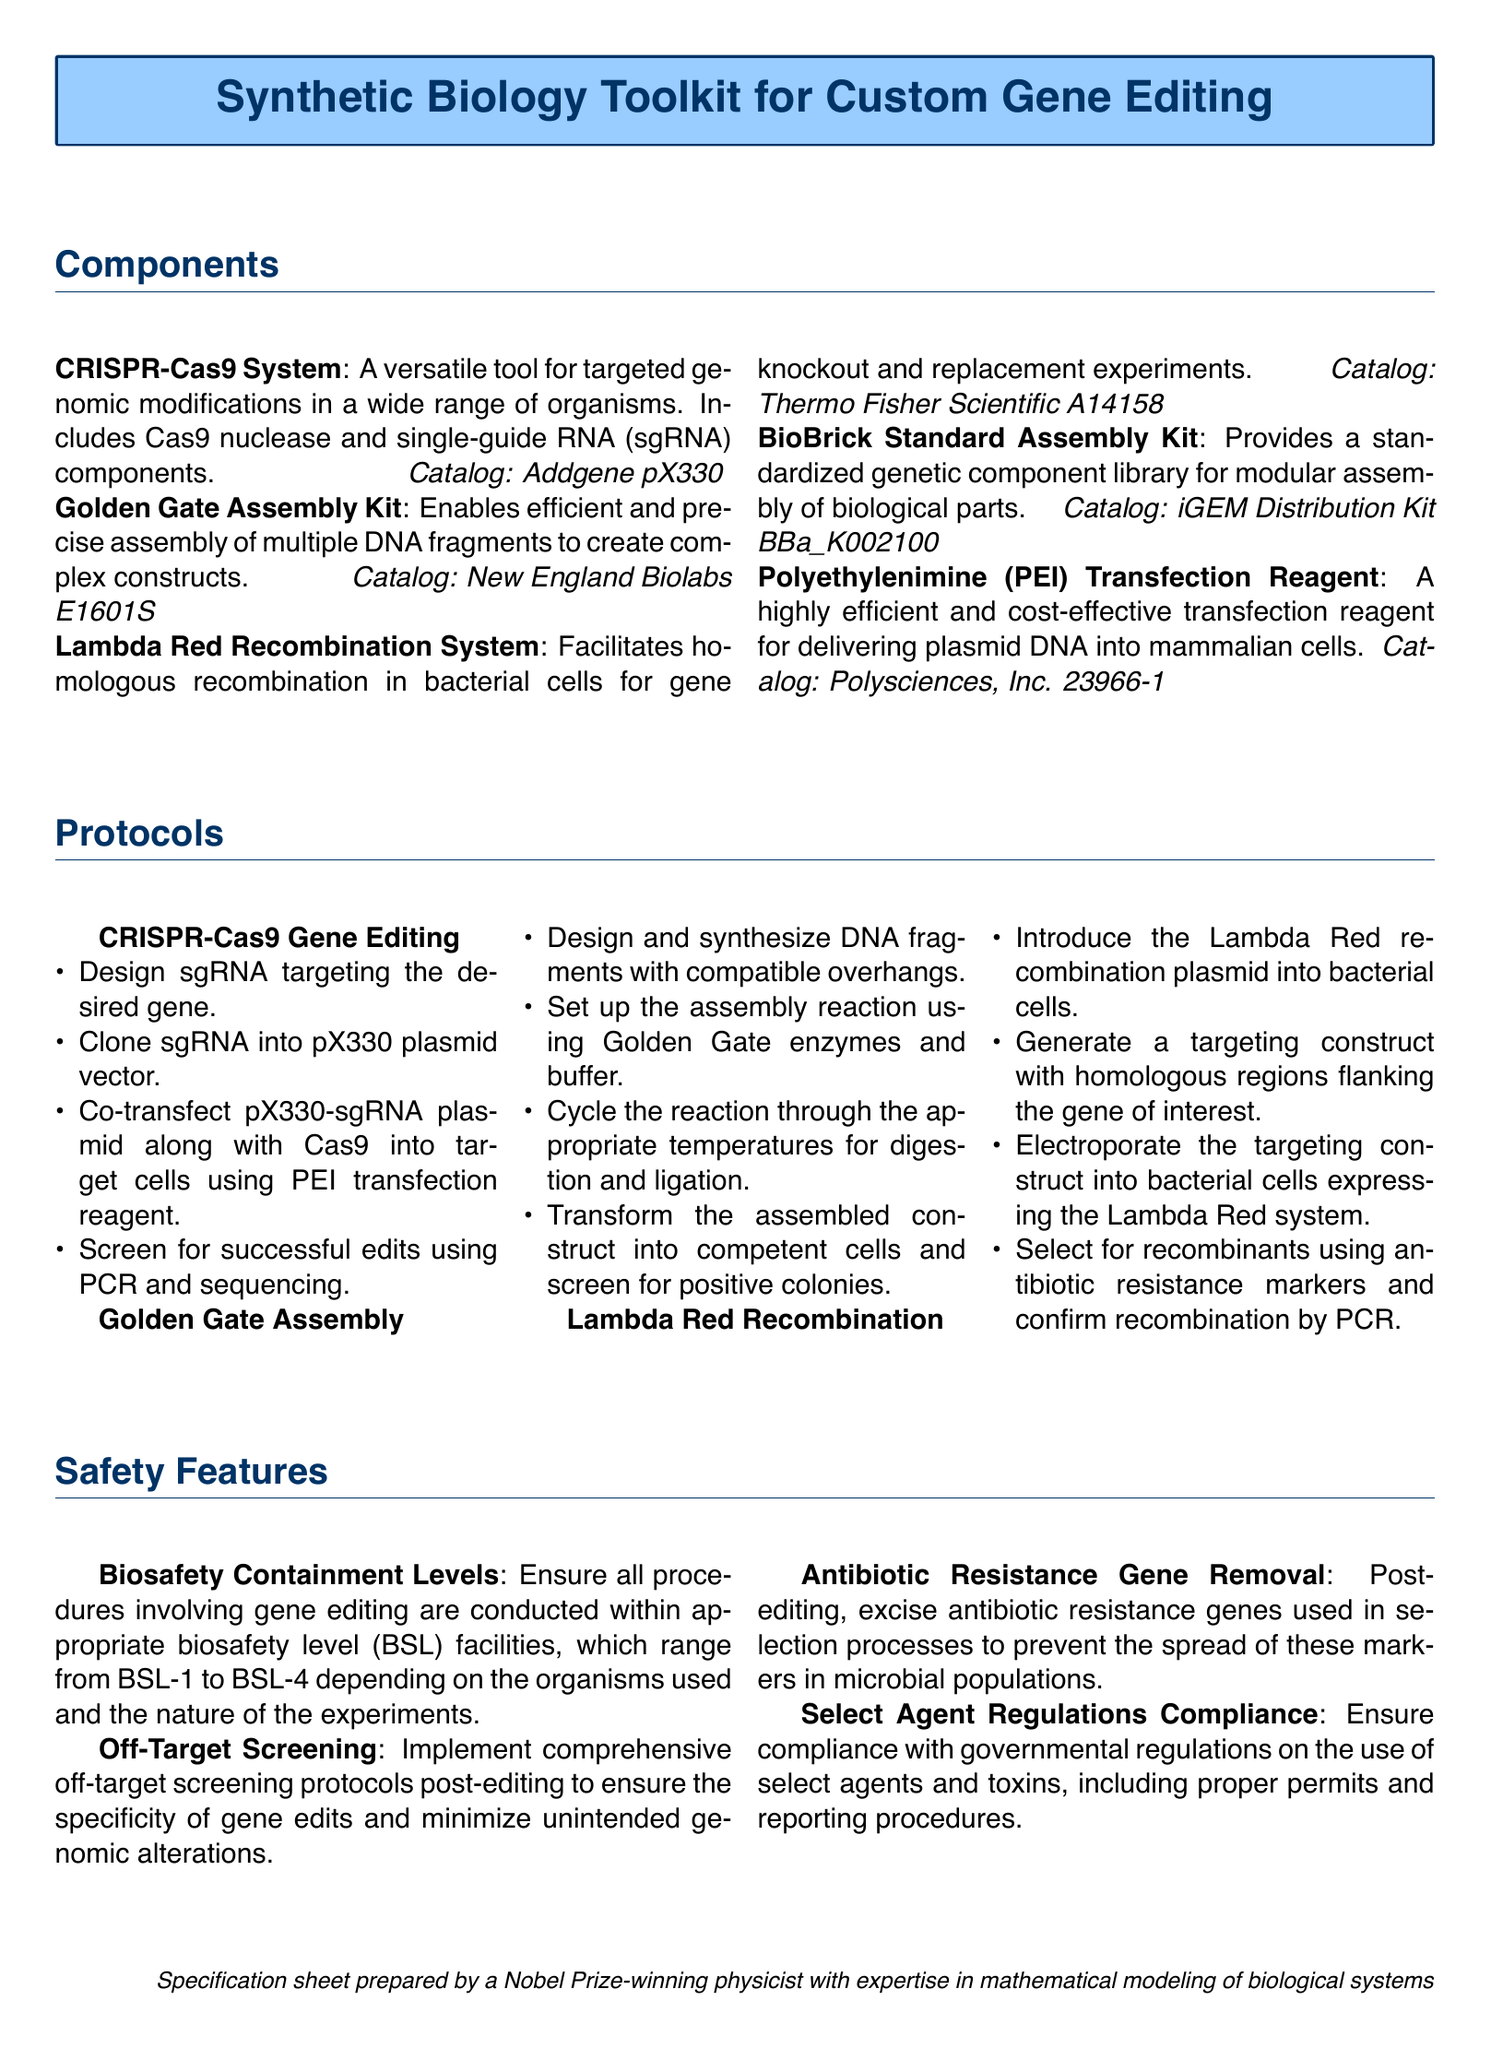What is the main purpose of the toolkit? The toolkit is designed for custom gene editing using synthetic biology techniques.
Answer: Custom gene editing What component is used for homologous recombination? This information is found in the Components section, specifying a system for gene knockout.
Answer: Lambda Red Recombination System What is a key safety feature regarding antibiotic resistance? This involves protocols to ensure genetic safety after editing practices are performed.
Answer: Antibiotic Resistance Gene Removal How many protocols are listed in the document? The number of protocols provided in the document can be counted in the Protocols section.
Answer: Three Which component allows for precise assembly of DNA fragments? The specific kit that facilitates the assembly of DNA fragments is mentioned under Components.
Answer: Golden Gate Assembly Kit What is the catalog number for the CRISPR-Cas9 System? The catalog number is included with the description of each component in the document.
Answer: Addgene pX330 What does BSL stand for in the safety features? The acronym refers to the containment levels essential for safety in gene editing procedures.
Answer: Biosafety Level Who prepared the specification sheet? The author of the specification sheet is mentioned at the bottom of the document.
Answer: A Nobel Prize-winning physicist What is the contact measurement for the document layout? This corresponds to the margins applied across the design and presentation of the document.
Answer: 1cm 